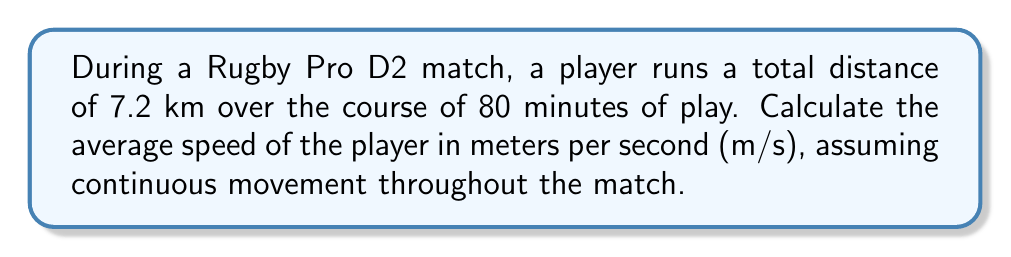Solve this math problem. To solve this problem, we'll follow these steps:

1. Convert the given distance from kilometers to meters:
   $7.2 \text{ km} = 7200 \text{ m}$

2. Convert the given time from minutes to seconds:
   $80 \text{ minutes} = 80 \times 60 = 4800 \text{ seconds}$

3. Use the formula for average speed:
   $$\text{Average Speed} = \frac{\text{Total Distance}}{\text{Total Time}}$$

4. Substitute the values into the formula:
   $$\text{Average Speed} = \frac{7200 \text{ m}}{4800 \text{ s}}$$

5. Perform the division:
   $$\text{Average Speed} = 1.5 \text{ m/s}$$

Therefore, the average speed of the rugby player during the match is 1.5 m/s.
Answer: 1.5 m/s 